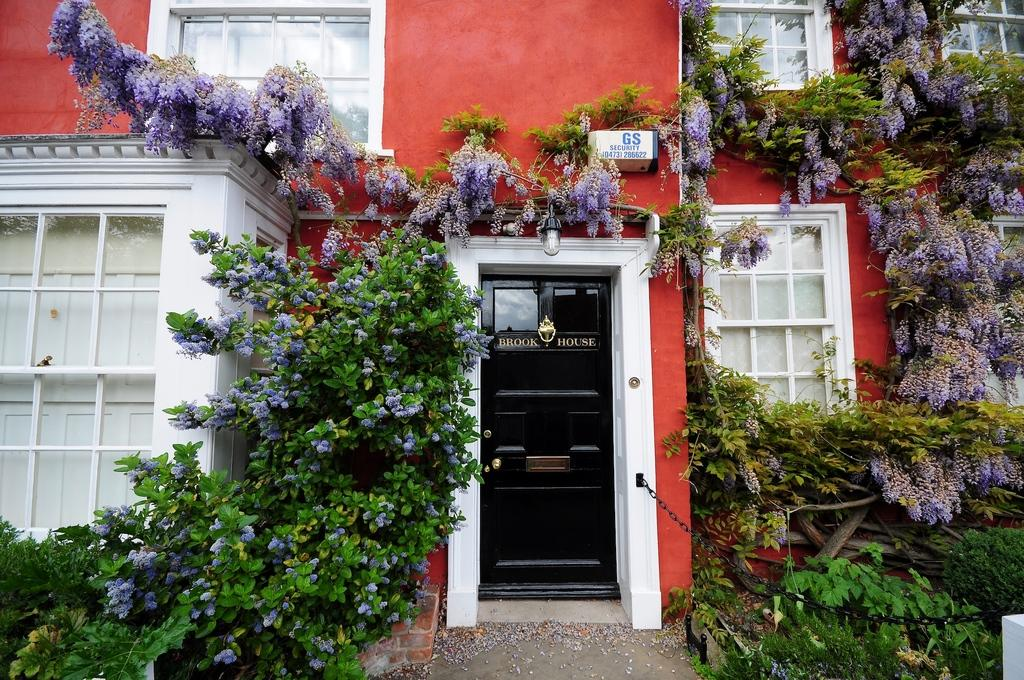What type of structure is visible in the image? There is a building in the image. What features can be seen on the building? The building has windows and a door. What additional objects are present in the image? There is a board, a light, plants, a chain, and flowers in the image. How many boys are playing with jam in the image? There are no boys or jam present in the image. What type of cellar can be seen in the image? There is no cellar visible in the image; it features a building, windows, a door, a board, a light, plants, a chain, and flowers. 